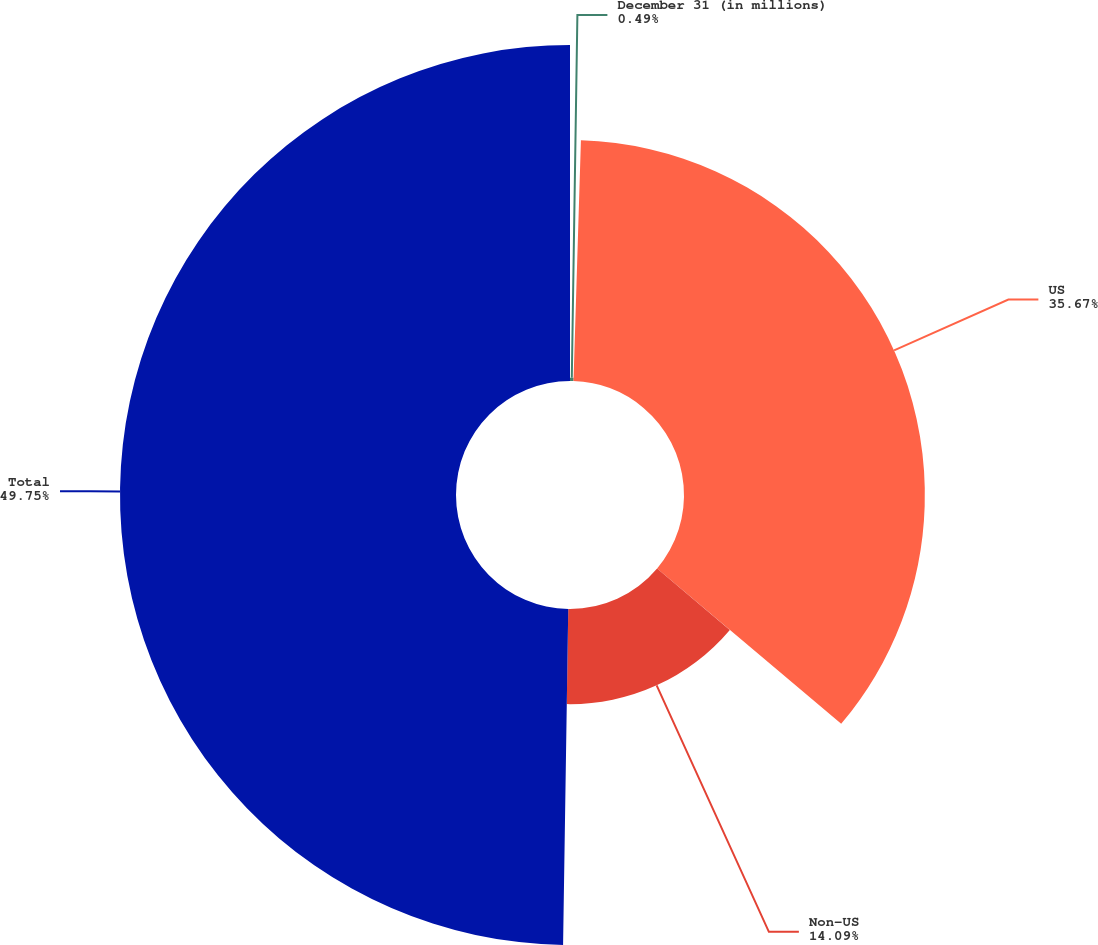<chart> <loc_0><loc_0><loc_500><loc_500><pie_chart><fcel>December 31 (in millions)<fcel>US<fcel>Non-US<fcel>Total<nl><fcel>0.49%<fcel>35.67%<fcel>14.09%<fcel>49.76%<nl></chart> 